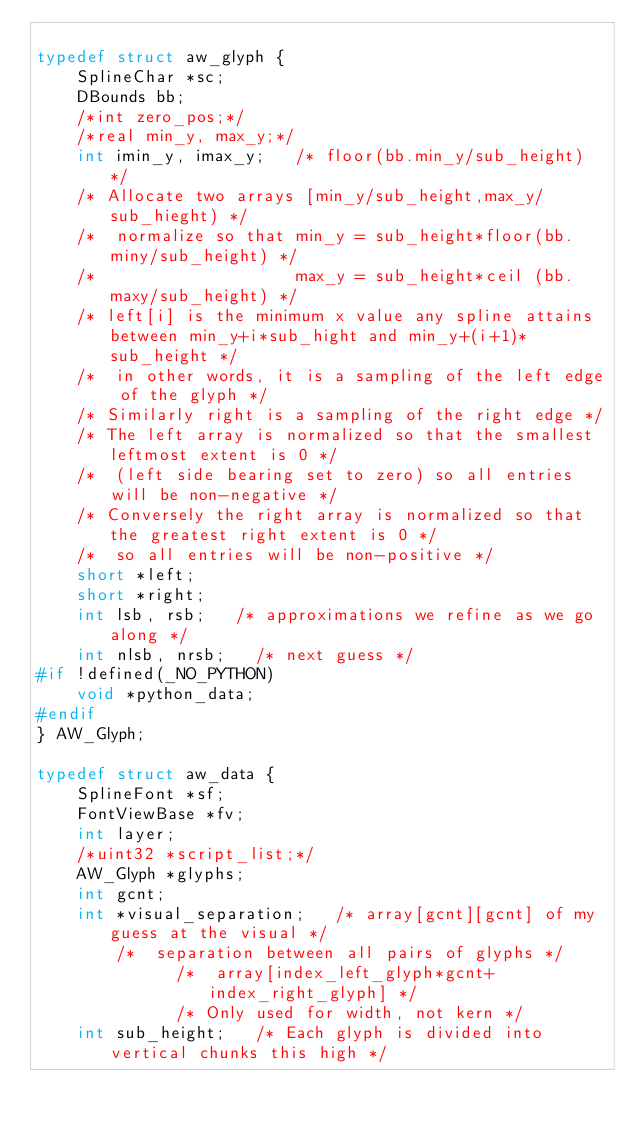Convert code to text. <code><loc_0><loc_0><loc_500><loc_500><_C_>
typedef struct aw_glyph {
    SplineChar *sc;
    DBounds bb;
    /*int zero_pos;*/
    /*real min_y, max_y;*/
    int imin_y, imax_y;		/* floor(bb.min_y/sub_height) */
    /* Allocate two arrays [min_y/sub_height,max_y/sub_hieght) */
    /*  normalize so that min_y = sub_height*floor(bb.miny/sub_height) */
    /*                    max_y = sub_height*ceil (bb.maxy/sub_height) */
    /* left[i] is the minimum x value any spline attains between min_y+i*sub_hight and min_y+(i+1)*sub_height */
    /*  in other words, it is a sampling of the left edge of the glyph */
    /* Similarly right is a sampling of the right edge */
    /* The left array is normalized so that the smallest leftmost extent is 0 */
    /*  (left side bearing set to zero) so all entries will be non-negative */
    /* Conversely the right array is normalized so that the greatest right extent is 0 */
    /*  so all entries will be non-positive */
    short *left;
    short *right;
    int lsb, rsb;		/* approximations we refine as we go along */
    int nlsb, nrsb;		/* next guess */
#if !defined(_NO_PYTHON)
    void *python_data;
#endif
} AW_Glyph;

typedef struct aw_data {
    SplineFont *sf;
    FontViewBase *fv;
    int layer;
    /*uint32 *script_list;*/
    AW_Glyph *glyphs;
    int gcnt;
    int *visual_separation; 	/* array[gcnt][gcnt] of my guess at the visual */
				/*  separation between all pairs of glyphs */
			        /*  array[index_left_glyph*gcnt+index_right_glyph] */
			        /* Only used for width, not kern */
    int sub_height;		/* Each glyph is divided into vertical chunks this high */</code> 